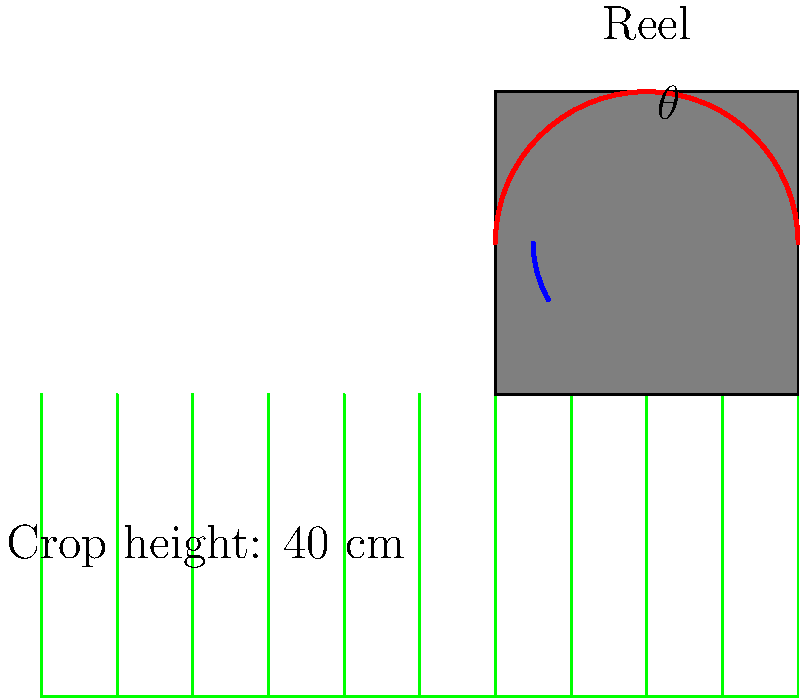A combine harvester's reel angle ($\theta$) needs to be optimized for a crop height of 40 cm. If the optimal reel angle is given by the formula $\theta = 90^\circ + \arctan(\frac{h}{2r})$, where $h$ is the crop height in centimeters and $r$ is the reel radius of 20 cm, what is the optimal reel angle for this crop? To find the optimal reel angle, we'll follow these steps:

1. Identify the given values:
   - Crop height (h) = 40 cm
   - Reel radius (r) = 20 cm

2. Use the formula: $\theta = 90^\circ + \arctan(\frac{h}{2r})$

3. Substitute the values into the formula:
   $\theta = 90^\circ + \arctan(\frac{40}{2(20)})$

4. Simplify the fraction inside the arctangent:
   $\theta = 90^\circ + \arctan(\frac{40}{40}) = 90^\circ + \arctan(1)$

5. Calculate the arctangent of 1:
   $\arctan(1) = 45^\circ$

6. Add the results:
   $\theta = 90^\circ + 45^\circ = 135^\circ$

Therefore, the optimal reel angle for a crop height of 40 cm is 135°.
Answer: 135° 